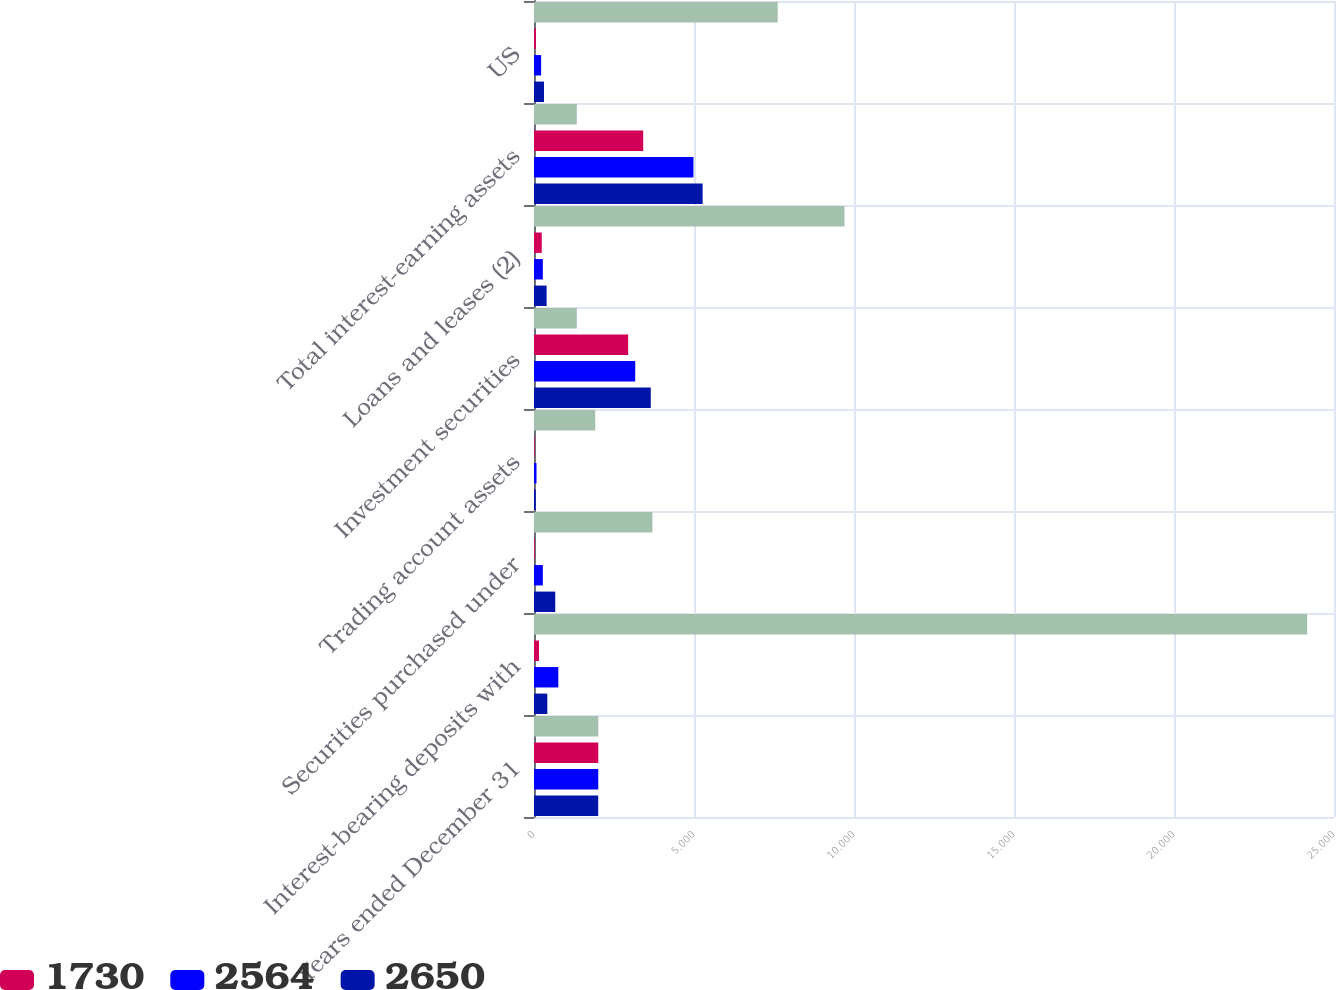Convert chart. <chart><loc_0><loc_0><loc_500><loc_500><stacked_bar_chart><ecel><fcel>Years ended December 31<fcel>Interest-bearing deposits with<fcel>Securities purchased under<fcel>Trading account assets<fcel>Investment securities<fcel>Loans and leases (2)<fcel>Total interest-earning assets<fcel>US<nl><fcel>nan<fcel>2009<fcel>24162<fcel>3701<fcel>1914<fcel>1337<fcel>9703<fcel>1337<fcel>7616<nl><fcel>1730<fcel>2009<fcel>156<fcel>24<fcel>20<fcel>2943<fcel>242<fcel>3412<fcel>61<nl><fcel>2564<fcel>2008<fcel>760<fcel>276<fcel>78<fcel>3163<fcel>276<fcel>4983<fcel>223<nl><fcel>2650<fcel>2007<fcel>416<fcel>664<fcel>55<fcel>3649<fcel>394<fcel>5270<fcel>313<nl></chart> 